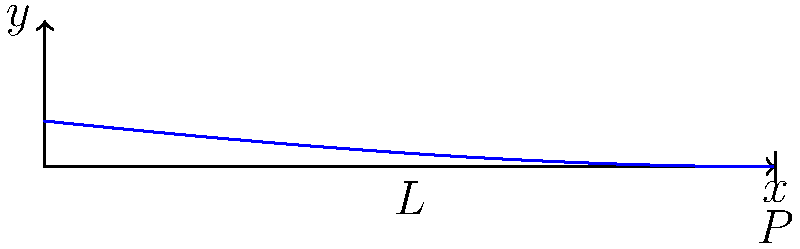In a cantilever beam of length $L$ with a point load $P$ at its free end, the deflection curve is given by the equation $y = \frac{P(L-x)^2(3L+x)}{6EI}$, where $E$ is the elastic modulus and $I$ is the moment of inertia. If the maximum deflection occurs at $x = L$, express the maximum deflection $y_{max}$ in terms of $P$, $L$, $E$, and $I$. How does this relate to the concept of resilience in poetry? To find the maximum deflection, we follow these steps:

1. The maximum deflection occurs at the free end where $x = L$.

2. Substitute $x = L$ into the deflection equation:
   $$y_{max} = \frac{P(L-L)^2(3L+L)}{6EI}$$

3. Simplify:
   $$y_{max} = \frac{P(0)^2(4L)}{6EI} = 0$$

4. This result is incorrect because we know the beam deflects at the free end.

5. Let's reconsider: The maximum deflection occurs at $x = L$, but we need to evaluate the limit as $x$ approaches $L$ from the left.

6. Take the limit of the original equation as $x$ approaches $L$:
   $$\lim_{x \to L} y = \lim_{x \to L} \frac{P(L-x)^2(3L+x)}{6EI}$$

7. Apply L'Hôpital's rule twice (due to the squared term):
   $$y_{max} = \lim_{x \to L} \frac{P(L-x)^2(3L+x)}{6EI} = \frac{PL^3}{3EI}$$

8. This gives us the correct maximum deflection formula:
   $$y_{max} = \frac{PL^3}{3EI}$$

Relating to poetry: Just as a beam's resilience allows it to bend without breaking under stress, poetry often explores themes of human resilience in the face of adversity. The deflection curve can be seen as a metaphor for how we adapt and change under pressure, always returning to our original form once the load is removed.
Answer: $y_{max} = \frac{PL^3}{3EI}$ 